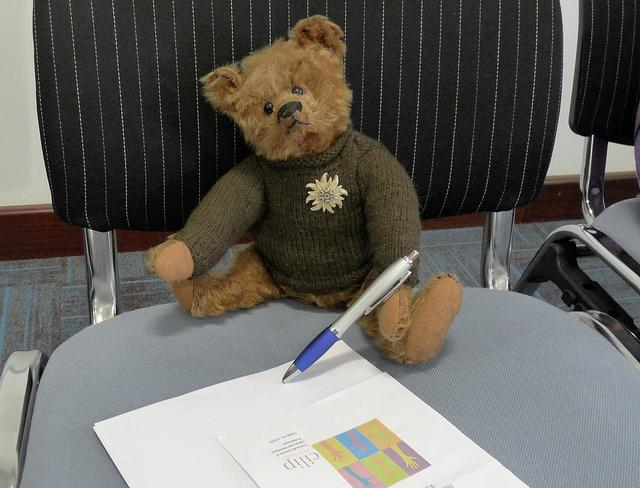What is the pen used to do on the paper? Please explain your reasoning. write. This is pretty commonly accepted and known application for a pen on paper. 